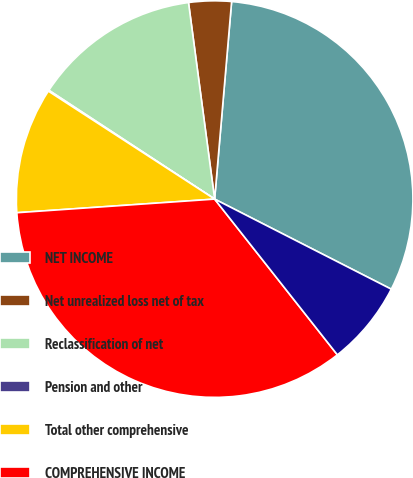<chart> <loc_0><loc_0><loc_500><loc_500><pie_chart><fcel>NET INCOME<fcel>Net unrealized loss net of tax<fcel>Reclassification of net<fcel>Pension and other<fcel>Total other comprehensive<fcel>COMPREHENSIVE INCOME<fcel>Less Comprehensive income<nl><fcel>31.14%<fcel>3.47%<fcel>13.65%<fcel>0.08%<fcel>10.26%<fcel>34.53%<fcel>6.87%<nl></chart> 